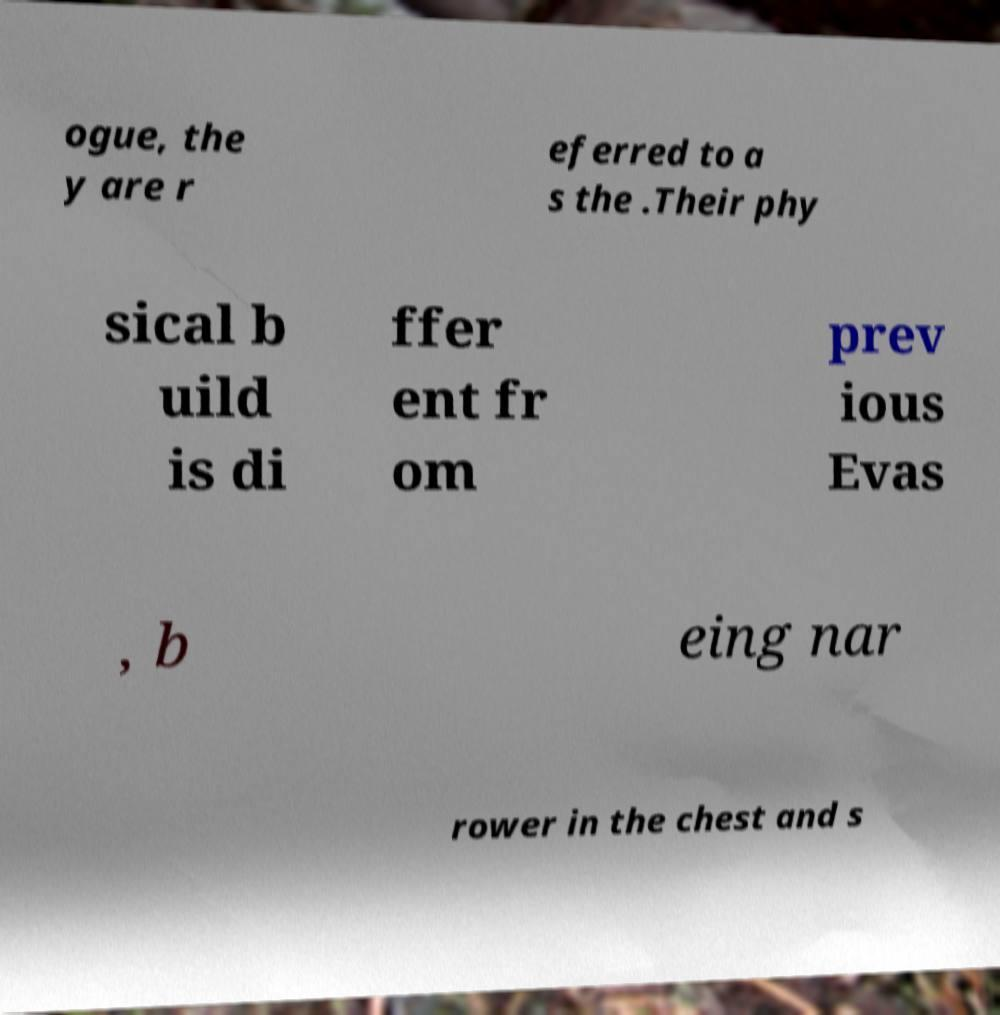Could you extract and type out the text from this image? ogue, the y are r eferred to a s the .Their phy sical b uild is di ffer ent fr om prev ious Evas , b eing nar rower in the chest and s 